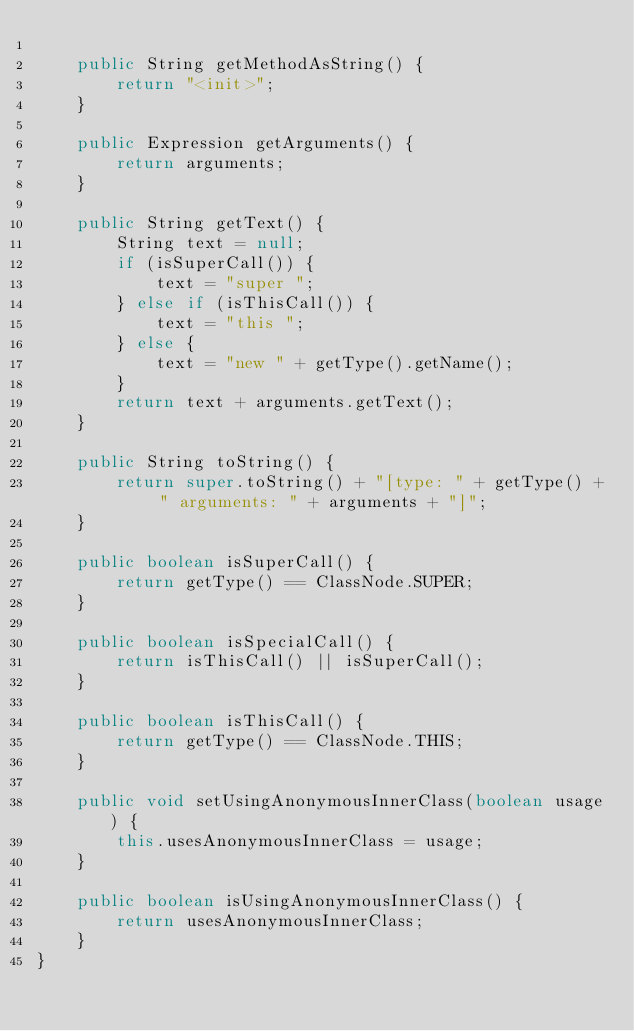Convert code to text. <code><loc_0><loc_0><loc_500><loc_500><_Java_>
    public String getMethodAsString() {
        return "<init>";
    }

    public Expression getArguments() {
        return arguments;
    }

    public String getText() {
        String text = null;
        if (isSuperCall()) {
            text = "super ";
        } else if (isThisCall()) {
            text = "this ";
        } else {
            text = "new " + getType().getName();
        }
        return text + arguments.getText();
    }

    public String toString() {
        return super.toString() + "[type: " + getType() + " arguments: " + arguments + "]";
    }

    public boolean isSuperCall() {
        return getType() == ClassNode.SUPER;
    }

    public boolean isSpecialCall() {
        return isThisCall() || isSuperCall();
    }

    public boolean isThisCall() {
        return getType() == ClassNode.THIS;
    }

    public void setUsingAnonymousInnerClass(boolean usage) {
        this.usesAnonymousInnerClass = usage;
    }

    public boolean isUsingAnonymousInnerClass() {
        return usesAnonymousInnerClass;
    }
}
</code> 